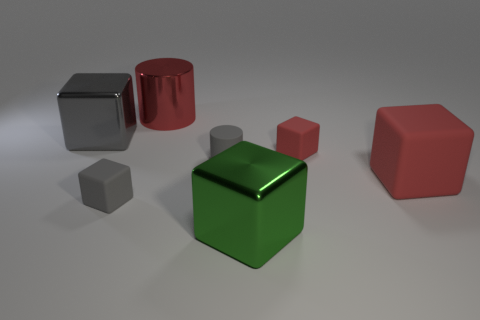Can you tell me about the different objects and their colors present in this image? Certainly! The image displays a collection of geometric shapes. There's a reflective silver cube, a shiny red cylinder, a smaller matte gray cube, a vibrant green cube, and a red cube with a slightly textured surface. The variety of shapes and their surfaces can give insight into concepts like geometry, light reflection, and texture.  How could these objects be used to explain the concept of volume? These objects are perfect for a visual lesson in volume. For instance, the volume of a cube is found by raising the length of one of its sides to the third power. The cylinder's volume is calculated by multiplying the area of its base, which is a circle, by its height. Comparisons between these shapes can help illustrate how volume is determined for different three-dimensional figures. 